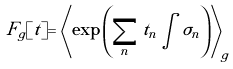Convert formula to latex. <formula><loc_0><loc_0><loc_500><loc_500>F _ { g } [ t ] = \left \langle \exp { \left ( \sum _ { n } t _ { n } \int \sigma _ { n } \right ) } \right \rangle _ { g }</formula> 